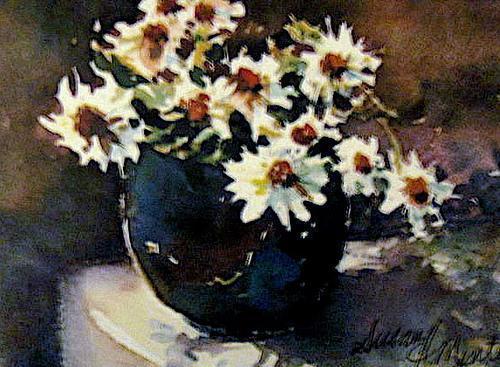How many people painted the painting?
Give a very brief answer. 1. How many vases are in the photo?
Give a very brief answer. 1. 